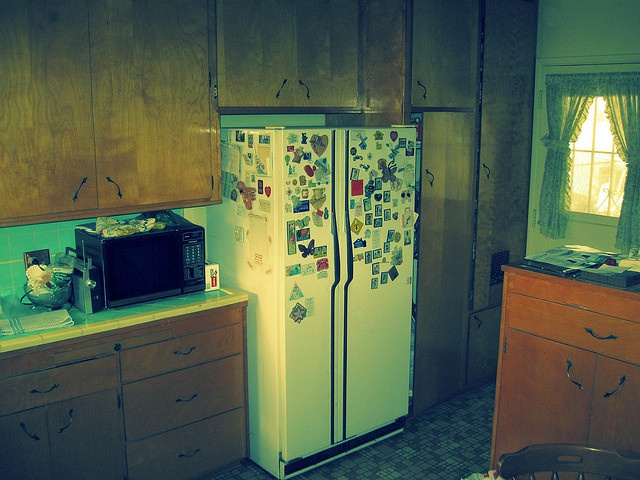Describe the objects in this image and their specific colors. I can see refrigerator in black, khaki, green, and teal tones, microwave in black, navy, teal, and green tones, and chair in black, darkblue, navy, purple, and gray tones in this image. 